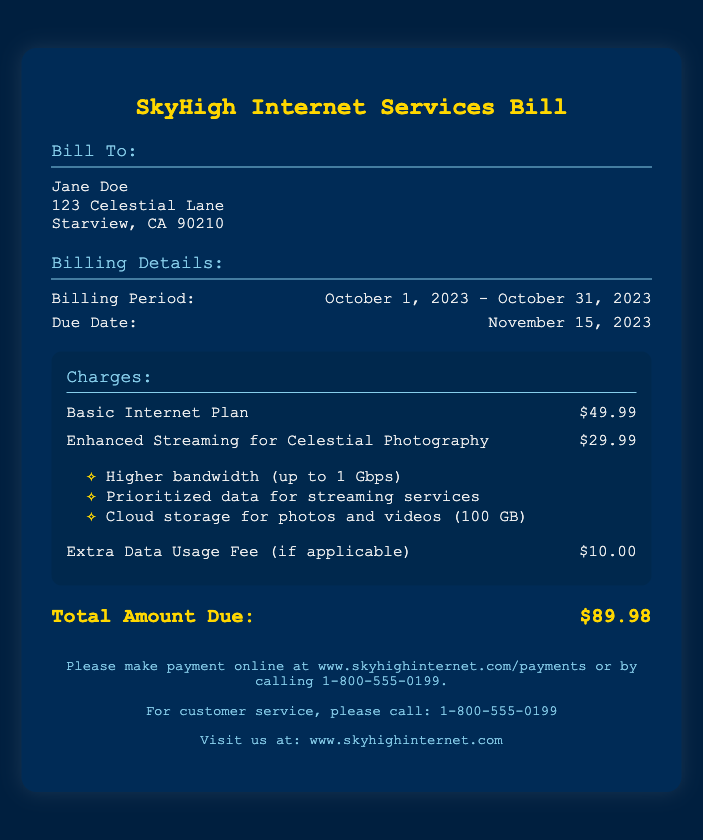What is the billing period? The billing period is specified in the document as the time frame for which the services were billed.
Answer: October 1, 2023 - October 31, 2023 What is the total amount due? The total amount due is the sum of all listed charges in the bill.
Answer: $89.98 What is the due date? The due date indicates when the bill payment should be made to avoid late fees.
Answer: November 15, 2023 How much does the enhanced streaming service cost? The enhanced streaming service includes specific features and its cost is provided separately in the charges section.
Answer: $29.99 What additional feature is provided with enhanced streaming? This feature is mentioned as part of the enhanced streaming service's benefits.
Answer: Cloud storage for photos and videos (100 GB) What is the basic internet plan cost? The document specifies how much is charged for the basic internet service.
Answer: $49.99 Are there any extra charges mentioned? The document indicates whether there are additional fees that may apply depending on usage.
Answer: $10.00 What service can customers use for payment? The document notes how customers can settle their bill, either online or on the phone.
Answer: www.skyhighinternet.com/payments What kind of data is prioritized under enhanced streaming? This question addresses the specific feature that enhances the user's ability to stream content smoothly.
Answer: Streaming services 